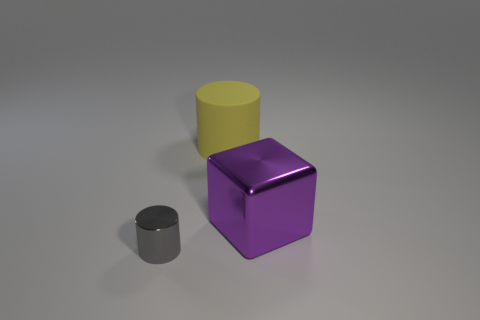Are there any other things that are the same shape as the large shiny object?
Your response must be concise. No. Is the shape of the large yellow object the same as the purple object?
Your answer should be very brief. No. There is a thing behind the metal object on the right side of the small thing; what color is it?
Make the answer very short. Yellow. What is the size of the object that is in front of the big yellow matte cylinder and on the left side of the large metal object?
Make the answer very short. Small. There is a big purple object that is made of the same material as the tiny gray cylinder; what shape is it?
Offer a very short reply. Cube. Does the big purple metal thing have the same shape as the thing that is to the left of the big matte thing?
Provide a short and direct response. No. What is the material of the object right of the big object behind the shiny block?
Offer a terse response. Metal. Is the number of purple shiny objects in front of the purple object the same as the number of blue metallic cylinders?
Give a very brief answer. Yes. Is there anything else that is made of the same material as the yellow cylinder?
Give a very brief answer. No. How many large things are right of the rubber cylinder and behind the cube?
Make the answer very short. 0. 